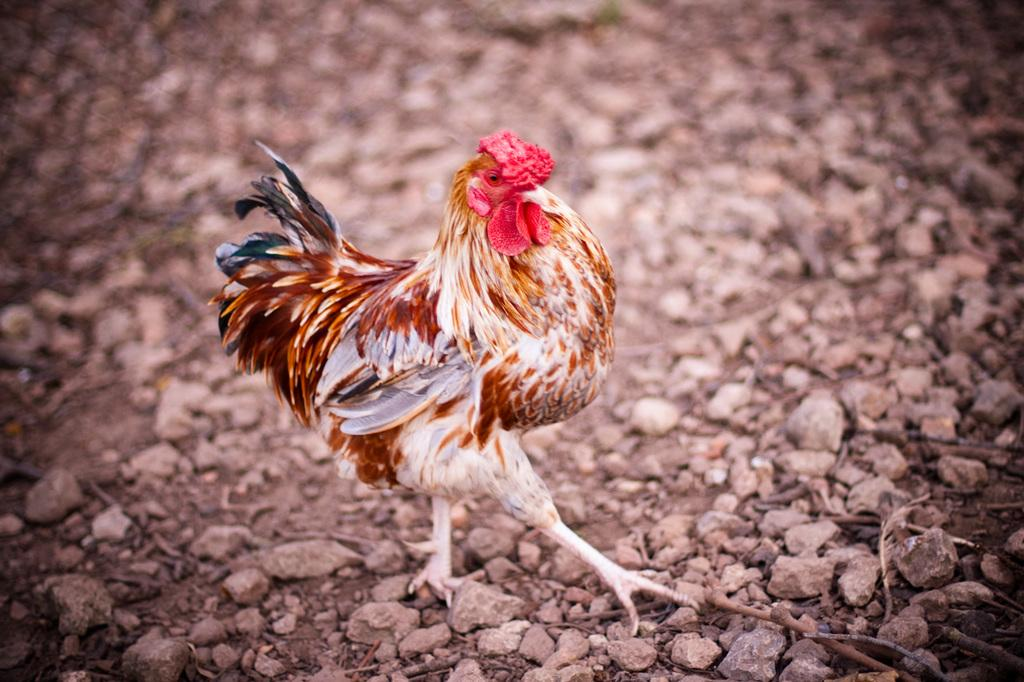What animal can be seen in the image? There is a hen in the image. What is the hen doing in the image? The hen is walking on the ground. What type of terrain is visible in the image? Small stones are visible in the image. Is the hen pulling a carriage in the image? No, there is no carriage present in the image, and the hen is not pulling anything. 